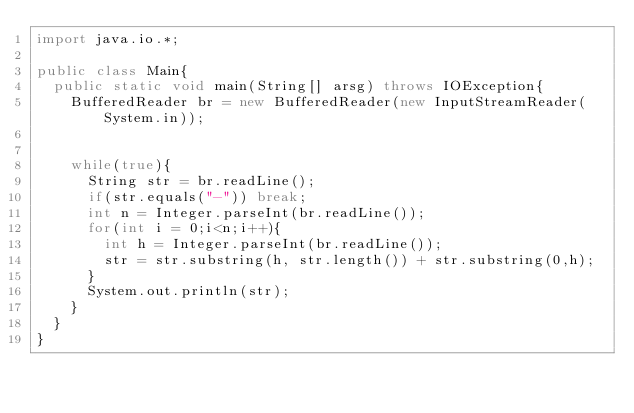<code> <loc_0><loc_0><loc_500><loc_500><_Java_>import java.io.*;

public class Main{
	public static void main(String[] arsg) throws IOException{
		BufferedReader br = new BufferedReader(new InputStreamReader(System.in));
		

		while(true){
			String str = br.readLine();
			if(str.equals("-")) break;
			int n = Integer.parseInt(br.readLine());
			for(int i = 0;i<n;i++){
				int h = Integer.parseInt(br.readLine());
				str = str.substring(h, str.length()) + str.substring(0,h);
			}
			System.out.println(str);
		}
	}
}</code> 